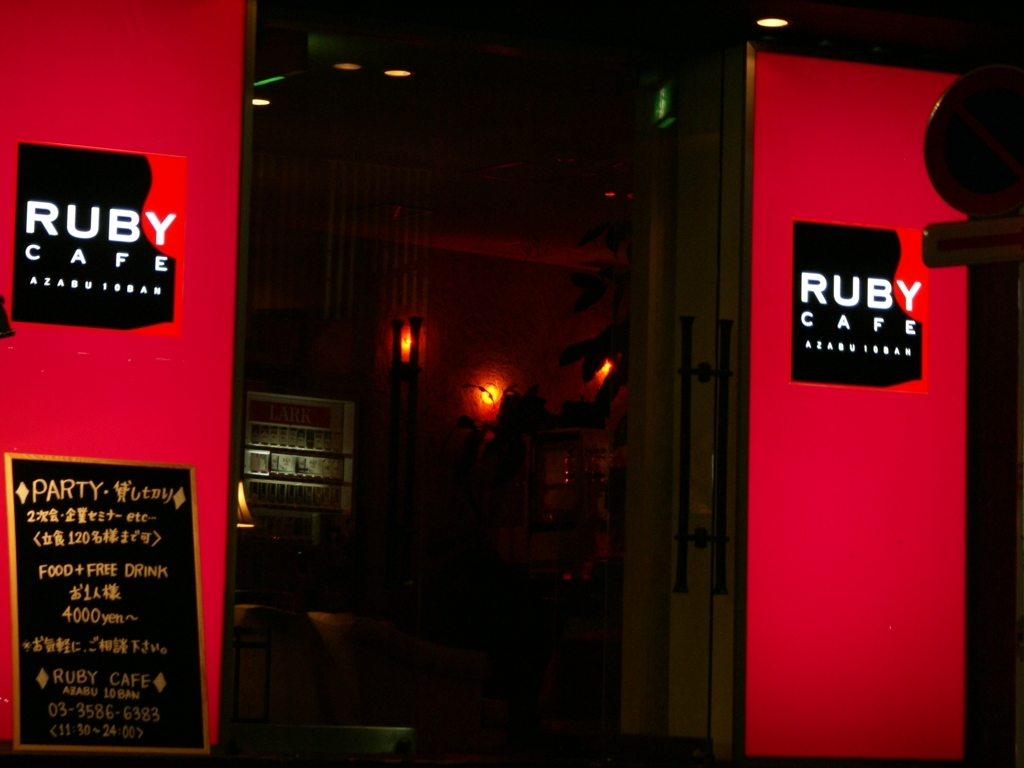What can be seen clearly in this photo?
A. Blurry images
B. Large objects in the center
C. Nothing
D. Small text in the bottom left corner
Answer with the option's letter from the given choices directly. The most prominent elements in the photo are the large, illuminated signs of 'RUBY CAFE' in the center, presenting a vibrant red color against the night. While there is indeed some small text in the bottom left corner, it is not the primary focus of the image. Therefore, a more accurate answer would be option B: B. Large objects in the center. 